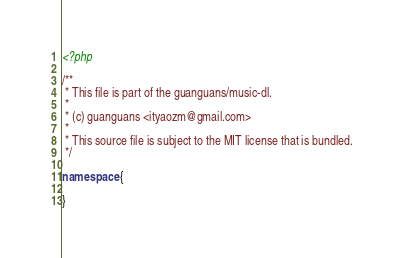Convert code to text. <code><loc_0><loc_0><loc_500><loc_500><_PHP_><?php

/**
 * This file is part of the guanguans/music-dl.
 *
 * (c) guanguans <ityaozm@gmail.com>
 *
 * This source file is subject to the MIT license that is bundled.
 */

namespace {

}
</code> 